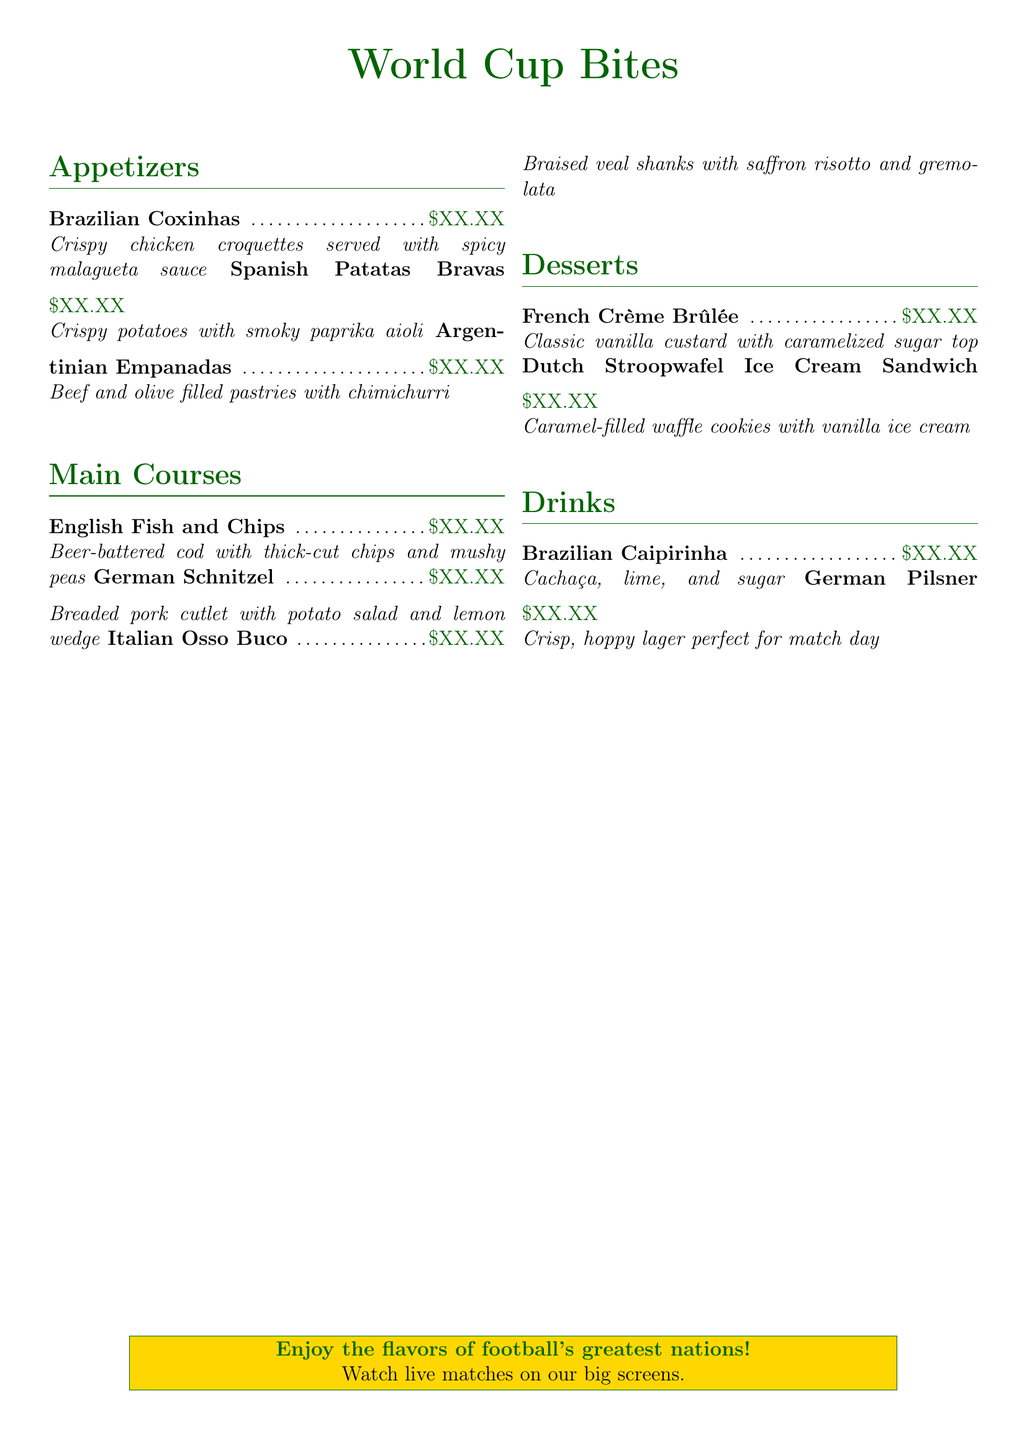What are the appetizers offered? The appetizers listed in the menu are Brazilian Coxinhas, Spanish Patatas Bravas, and Argentinian Empanadas.
Answer: Brazilian Coxinhas, Spanish Patatas Bravas, Argentinian Empanadas Which dish features beer-battered cod? The dish that features beer-battered cod is identified as English Fish and Chips.
Answer: English Fish and Chips What type of dessert is Stroopwafel Ice Cream Sandwich? Stroopwafel Ice Cream Sandwich is categorized under desserts, specifically showcasing Dutch cuisine.
Answer: Dutch Stroopwafel Ice Cream Sandwich How many main courses are listed in the menu? The menu lists three main courses: English Fish and Chips, German Schnitzel, and Italian Osso Buco.
Answer: 3 Which country’s drink is Caipirinha? Caipirinha is a drink that originates from Brazil.
Answer: Brazil What type of cuisine does the dish Osso Buco represent? Osso Buco represents Italian cuisine as noted in the menu.
Answer: Italian How many appetizers are there on the menu? The menu features three appetizers, which include various renowned international dishes.
Answer: 3 What color is the font for the title "World Cup Bites"? The font for the title "World Cup Bites" is colored football green.
Answer: football green 